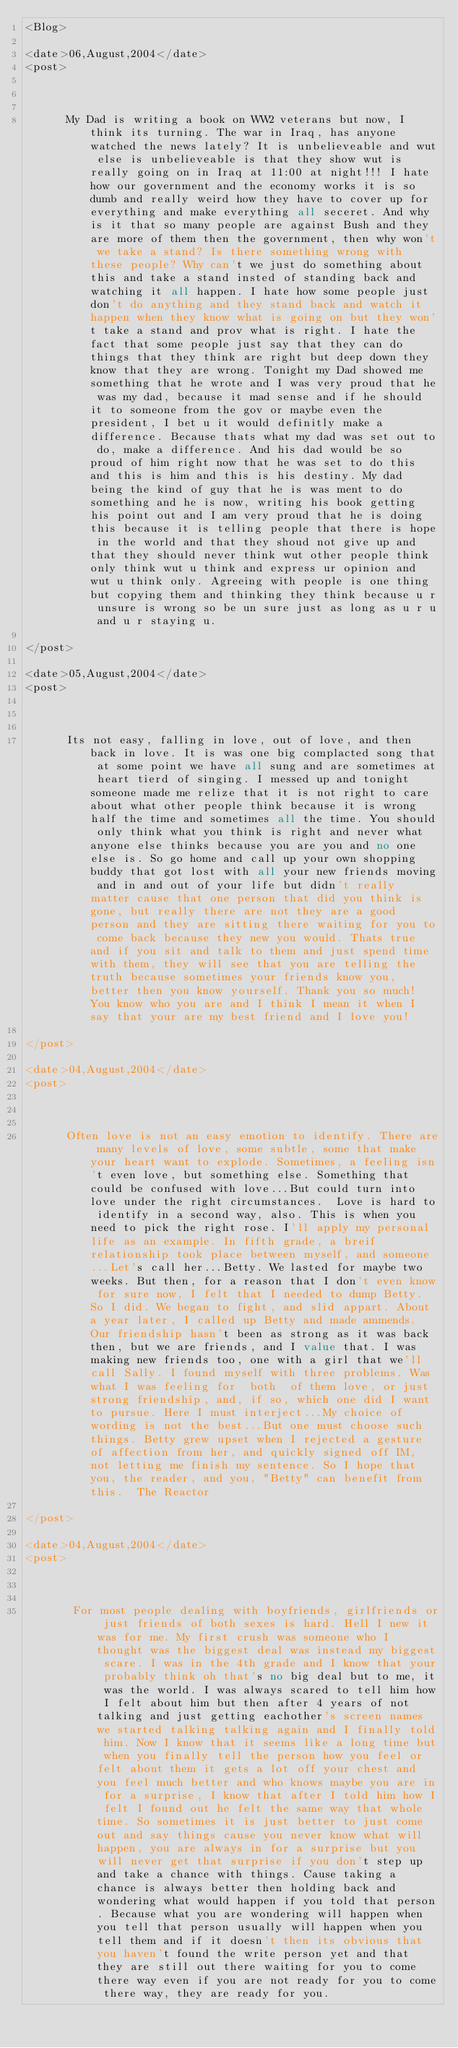Convert code to text. <code><loc_0><loc_0><loc_500><loc_500><_XML_><Blog>

<date>06,August,2004</date>
<post>

    
       
      My Dad is writing a book on WW2 veterans but now, I think its turning. The war in Iraq, has anyone watched the news lately? It is unbelieveable and wut else is unbelieveable is that they show wut is really going on in Iraq at 11:00 at night!!! I hate how our government and the economy works it is so dumb and really weird how they have to cover up for everything and make everything all seceret. And why is it that so many people are against Bush and they are more of them then the government, then why won't we take a stand? Is there something wrong with these people? Why can't we just do something about this and take a stand insted of standing back and watching it all happen. I hate how some people just don't do anything and they stand back and watch it happen when they know what is going on but they won't take a stand and prov what is right. I hate the fact that some people just say that they can do things that they think are right but deep down they know that they are wrong. Tonight my Dad showed me something that he wrote and I was very proud that he was my dad, because it mad sense and if he should it to someone from the gov or maybe even the president, I bet u it would definitly make a difference. Because thats what my dad was set out to do, make a difference. And his dad would be so proud of him right now that he was set to do this and this is him and this is his destiny. My dad being the kind of guy that he is was ment to do something and he is now, writing his book getting his point out and I am very proud that he is doing this because it is telling people that there is hope in the world and that they shoud not give up and that they should never think wut other people think only think wut u think and express ur opinion and wut u think only. Agreeing with people is one thing but copying them and thinking they think because u r unsure is wrong so be un sure just as long as u r u and u r staying u. 
      
</post>

<date>05,August,2004</date>
<post>

    
       
      Its not easy, falling in love, out of love, and then back in love. It is was one big complacted song that at some point we have all sung and are sometimes at heart tierd of singing. I messed up and tonight someone made me relize that it is not right to care about what other people think because it is wrong half the time and sometimes all the time. You should only think what you think is right and never what anyone else thinks because you are you and no one else is. So go home and call up your own shopping buddy that got lost with all your new friends moving and in and out of your life but didn't really matter cause that one person that did you think is gone, but really there are not they are a good person and they are sitting there waiting for you to come back because they new you would. Thats true and if you sit and talk to them and just spend time with them, they will see that you are telling the truth because sometimes your friends know you, better then you know yourself. Thank you so much! You know who you are and I think I mean it when I say that your are my best friend and I love you! 
      
</post>

<date>04,August,2004</date>
<post>

    
       
      Often love is not an easy emotion to identify. There are many levels of love, some subtle, some that make your heart want to explode. Sometimes, a feeling isn't even love, but something else. Something that could be confused with love...But could turn into love under the right circumstances.  Love is hard to identify in a second way, also. This is when you need to pick the right rose. I'll apply my personal life as an example. In fifth grade, a breif relationship took place between myself, and someone...Let's call her...Betty. We lasted for maybe two weeks. But then, for a reason that I don't even know for sure now, I felt that I needed to dump Betty. So I did. We began to fight, and slid appart. About a year later, I called up Betty and made ammends. Our friendship hasn't been as strong as it was back then, but we are friends, and I value that. I was making new friends too, one with a girl that we'll call Sally. I found myself with three problems. Was what I was feeling for  both  of them love, or just strong friendship, and, if so, which one did I want to pursue. Here I must interject...My choice of wording is not the best...But one must choose such things. Betty grew upset when I rejected a gesture of affection from her, and quickly signed off IM, not letting me finish my sentence. So I hope that you, the reader, and you, "Betty" can benefit from this.  The Reactor 
      
</post>

<date>04,August,2004</date>
<post>

    
       
       For most people dealing with boyfriends, girlfriends or just friends of both sexes is hard. Hell I new it was for me. My first crush was someone who I thought was the biggest deal was instead my biggest scare. I was in the 4th grade and I know that your probably think oh that's no big deal but to me, it was the world. I was always scared to tell him how I felt about him but then after 4 years of not talking and just getting eachother's screen names we started talking talking again and I finally told him. Now I know that it seems like a long time but when you finally tell the person how you feel or felt about them it gets a lot off your chest and you feel much better and who knows maybe you are in for a surprise, I know that after I told him how I felt I found out he felt the same way that whole time. So sometimes it is just better to just come out and say things cause you never know what will happen, you are always in for a surprise but you will never get that surprise if you don't step up and take a chance with things. Cause taking a chance is always better then holding back and wondering what would happen if you told that person. Because what you are wondering will happen when you tell that person usually will happen when you tell them and if it doesn't then its obvious that you haven't found the write person yet and that they are still out there waiting for you to come there way even if you are not ready for you to come there way, they are ready for you.   </code> 